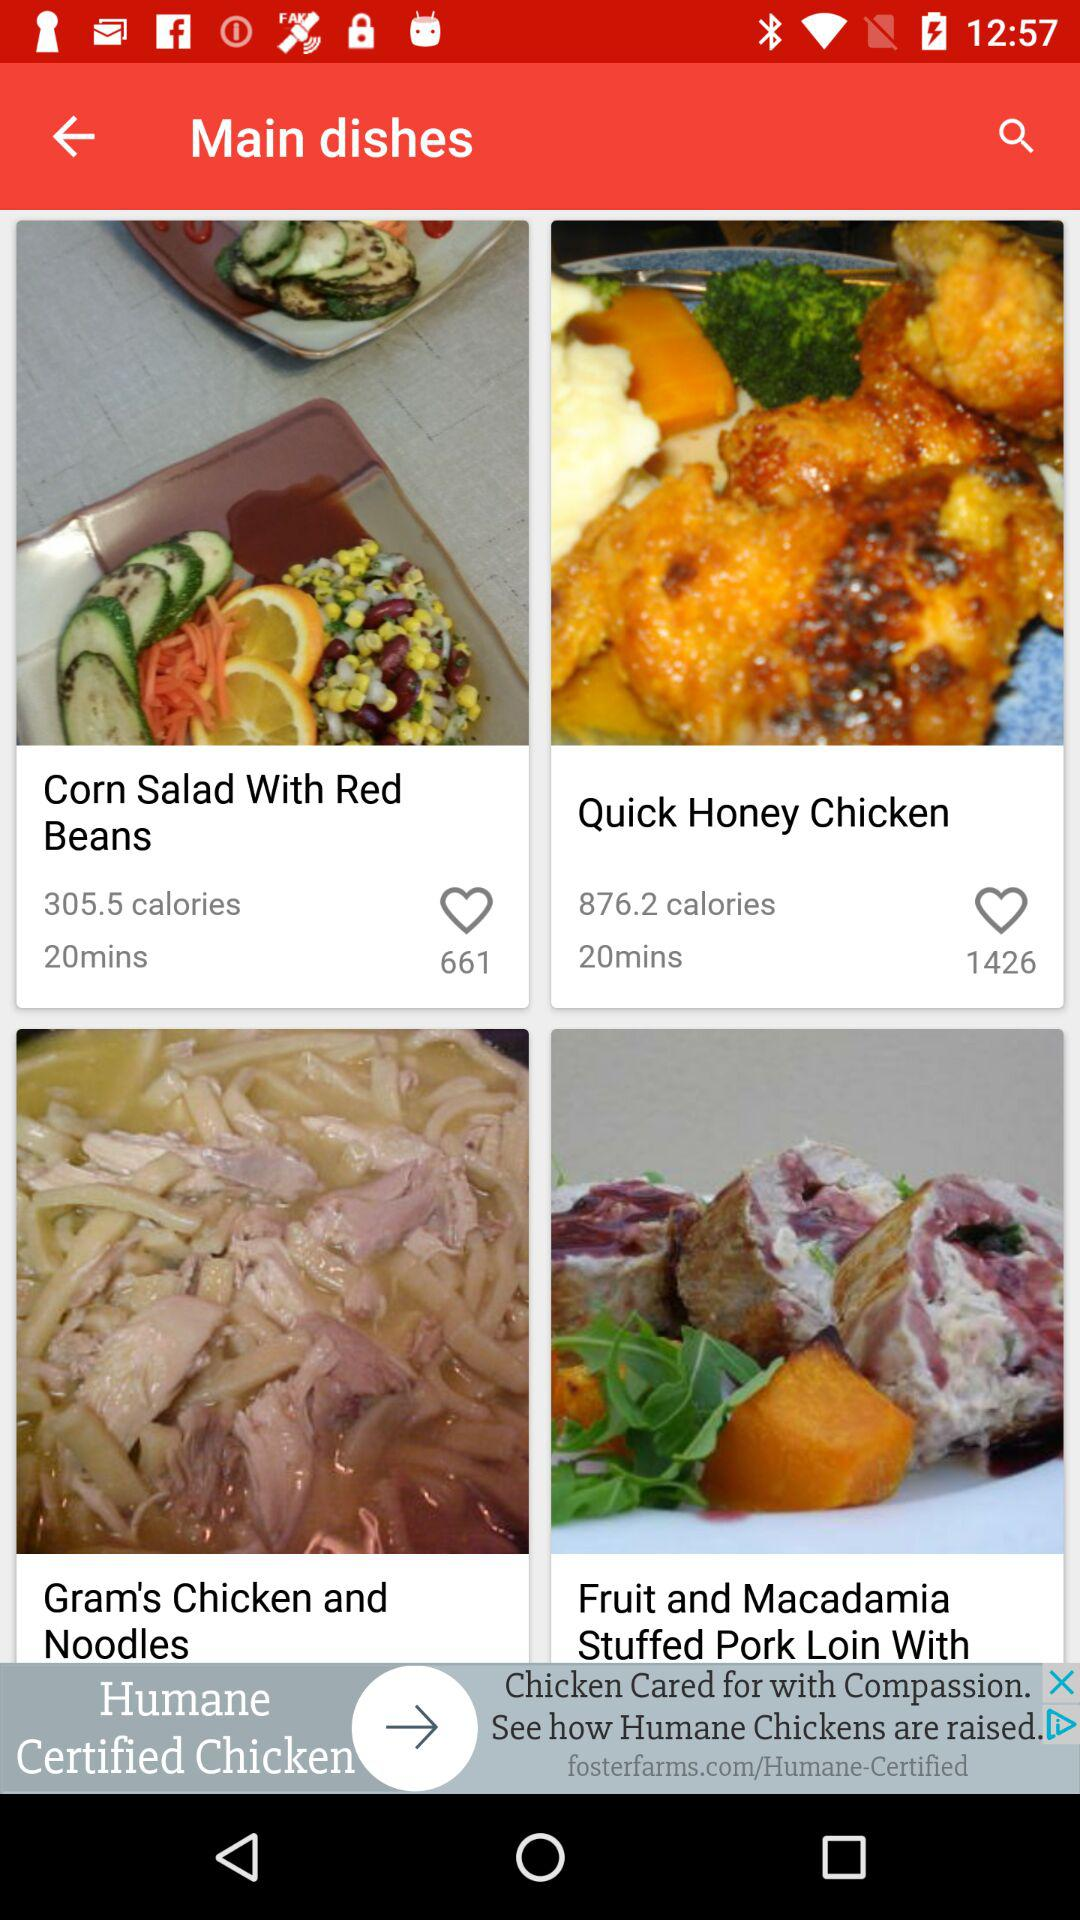Which dish has the most calories?
Answer the question using a single word or phrase. Quick Honey Chicken 